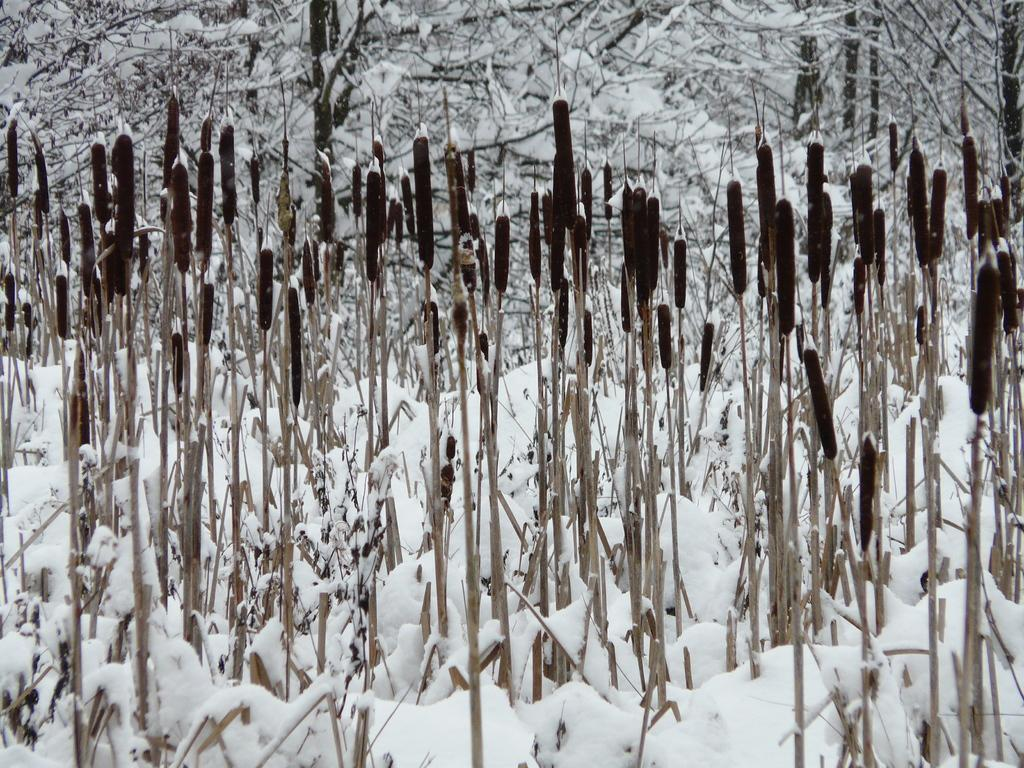What type of living organisms can be seen in the image? Plants can be seen in the image. What is the weather condition in the image? There is snow visible in the image, indicating a cold and snowy environment. What can be seen in the background of the image? In the background, there are trees covered with snow. What type of calculator can be seen in the image? There is no calculator present in the image. Is there a rat visible in the image? There is no rat present in the image. 